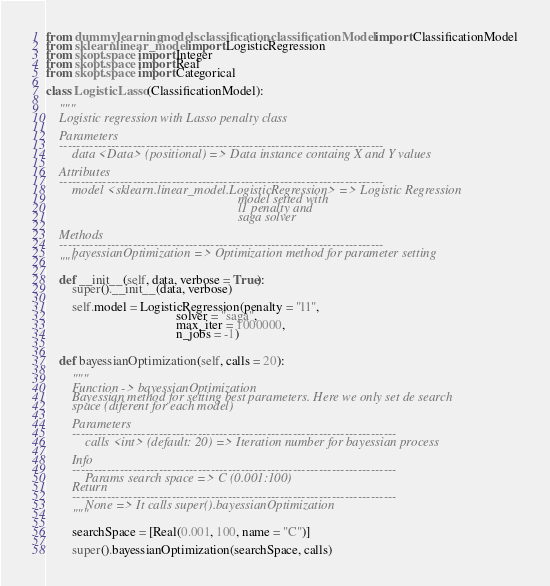<code> <loc_0><loc_0><loc_500><loc_500><_Python_>from dummylearning.models.classification.classificationModel import ClassificationModel
from sklearn.linear_model import LogisticRegression
from skopt.space import Integer
from skopt.space import Real
from skopt.space import Categorical

class LogisticLasso(ClassificationModel):

    """
    Logistic regression with Lasso penalty class

    Parameters
    ---------------------------------------------------------------------------
        data <Data> (positional) => Data instance containg X and Y values

    Attributes
    ---------------------------------------------------------------------------
        model <sklearn.linear_model.LogisticRegression> => Logistic Regression
                                                           model setted with
                                                           l1 penalty and
                                                           saga solver

    Methods
    ---------------------------------------------------------------------------
        bayessianOptimization => Optimization method for parameter setting
    """

    def __init__(self, data, verbose = True):
        super().__init__(data, verbose)

        self.model = LogisticRegression(penalty = "l1",
                                        solver = "saga",
                                        max_iter = 1000000,
                                        n_jobs = -1)


    def bayessianOptimization(self, calls = 20):

        """
        Function -> bayessianOptimization
        Bayessian method for setting best parameters. Here we only set de search
        space (diferent for each model)

        Parameters
        ---------------------------------------------------------------------------
            calls <int> (default: 20) => Iteration number for bayessian process

        Info
        ---------------------------------------------------------------------------
            Params search space => C (0.001:100)
        Return
        ---------------------------------------------------------------------------
            None => It calls super().bayessianOptimization
        """

        searchSpace = [Real(0.001, 100, name = "C")]

        super().bayessianOptimization(searchSpace, calls)</code> 